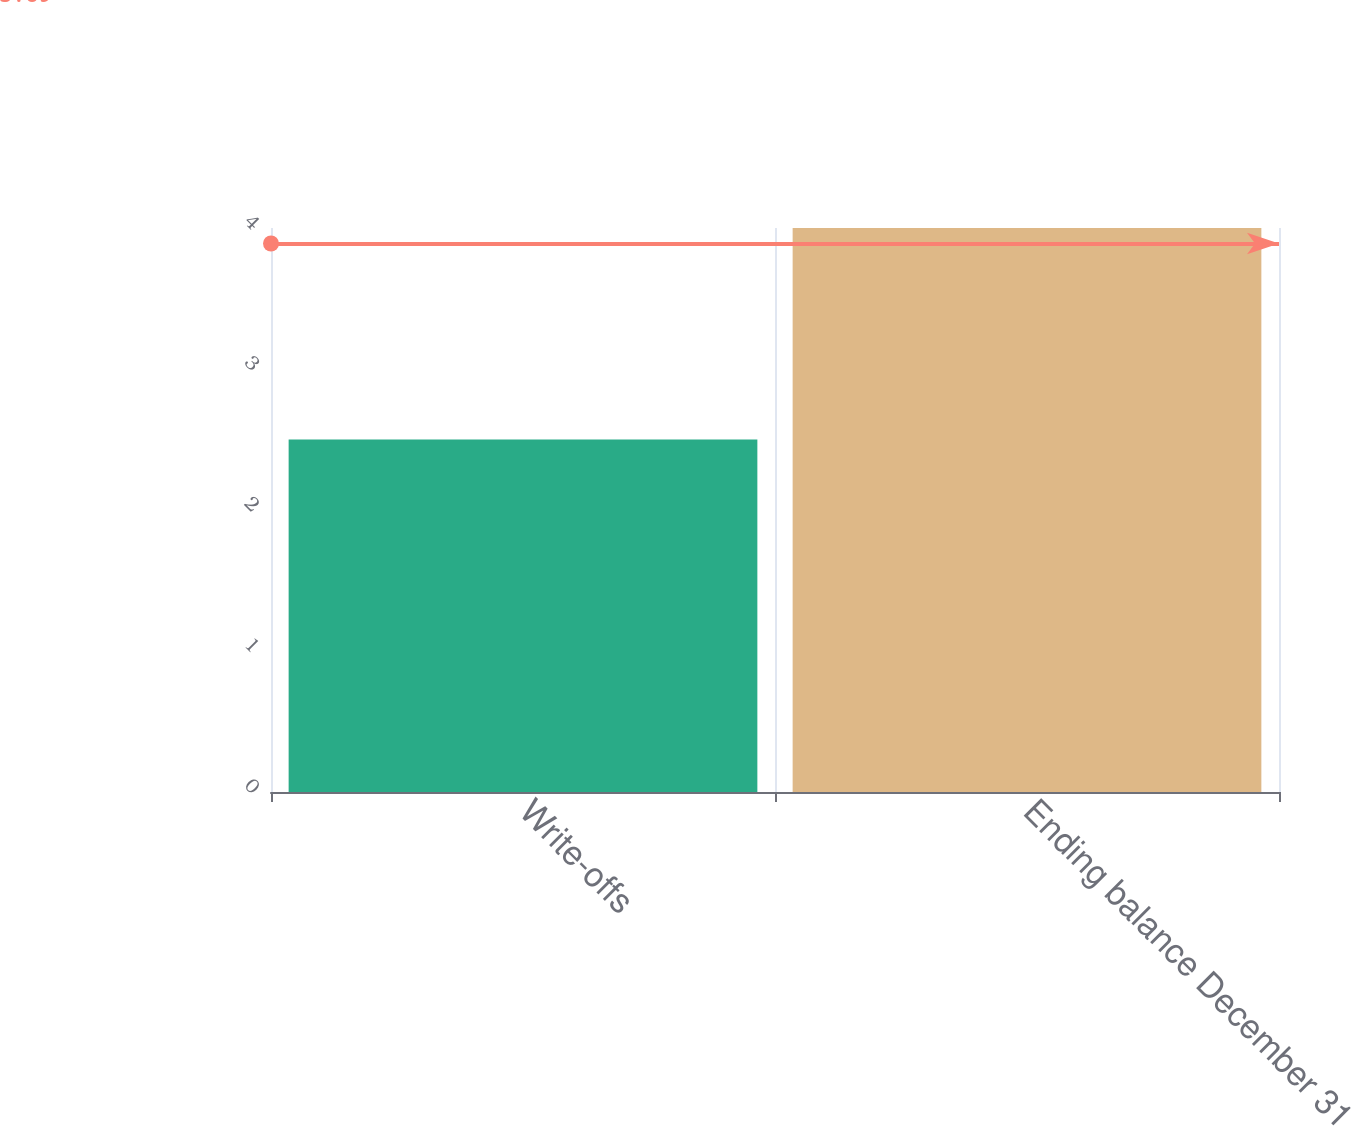Convert chart. <chart><loc_0><loc_0><loc_500><loc_500><bar_chart><fcel>Write-offs<fcel>Ending balance December 31<nl><fcel>2.5<fcel>4<nl></chart> 